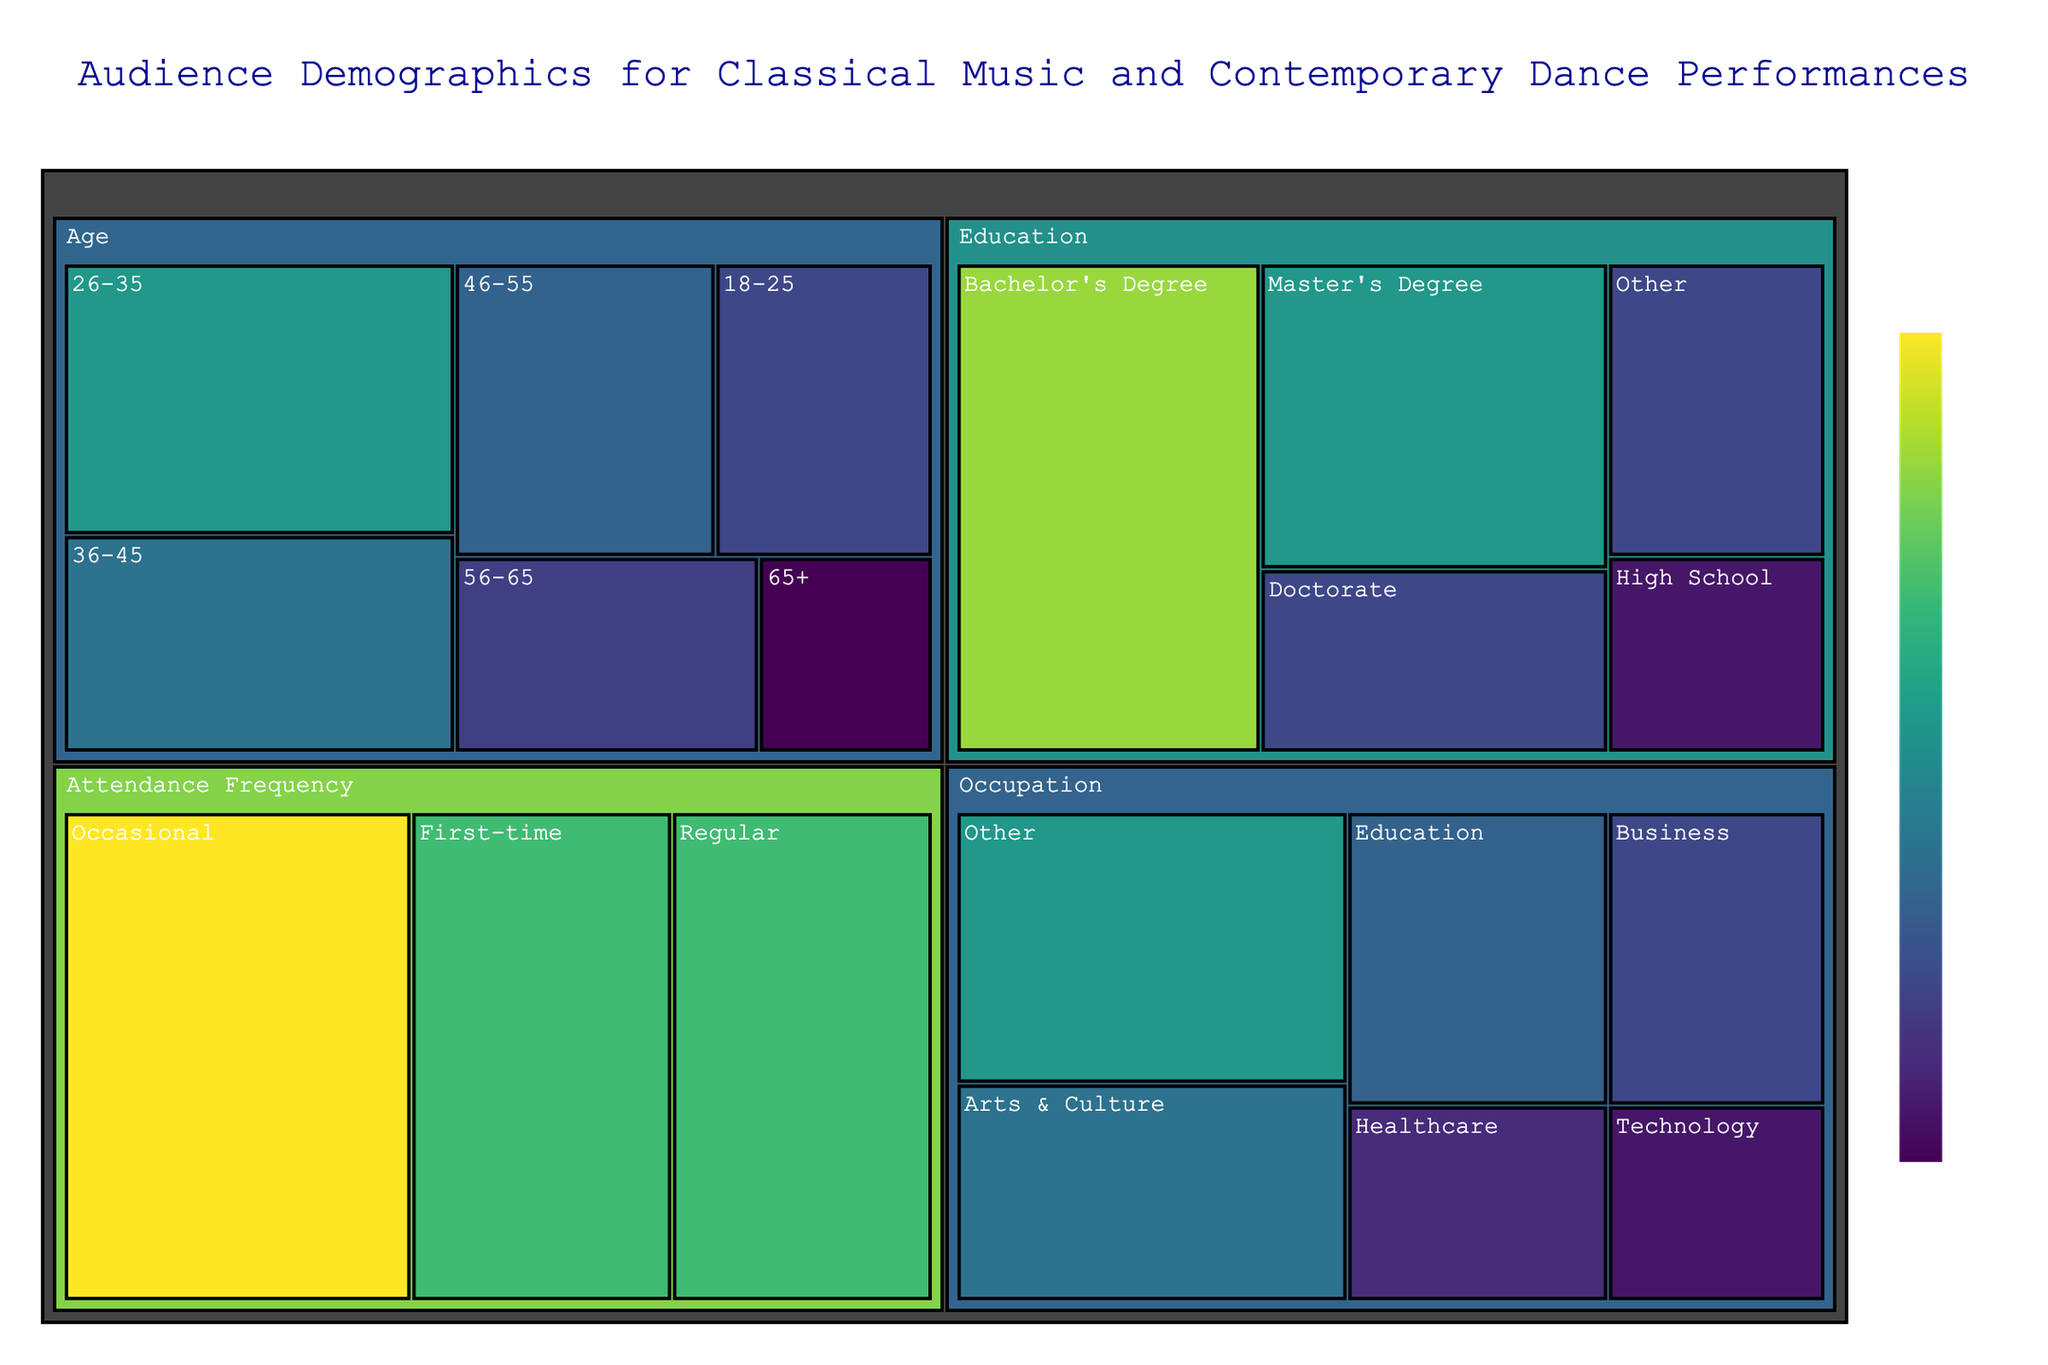What is the total number of audience members in the 18-25 age group? The treemap shows that the value for the 18-25 age group is 15. This information is available directly from the figure.
Answer: 15 What are the categories represented in the treemap? The treemap organizes data into different categories, which are visible as top-level labels. The categories are Age, Education, Occupation, and Attendance Frequency.
Answer: Age, Education, Occupation, Attendance Frequency Which subcategory in the Education category has the highest value? Within the Education category, the treemap shows the subcategories with their values. The Bachelor's Degree subcategory has the highest value at 35.
Answer: Bachelor's Degree What is the combined value of audience members with a Master's Degree and a Doctorate? To find the combined value, add the values of the Master's Degree (25) and Doctorate (15) subcategories. 25 + 15 = 40.
Answer: 40 How does the number of first-time attendees compare to regular attendees? According to the treemap, the value for First-time attendees is 30, while Regular attendees also have a value of 30. Both have the same number.
Answer: Same What percentage of audience members work in Technology? The total number of audience values must be summed first. Then, find the percentage of Technology workers which is 10. Total is 15 + 25 + 20 + 18 + 14 + 8 + 10 + 35 + 25 + 15 + 15 + 20 + 18 + 15 + 12 + 10 + 25 + 30 + 40 + 30 = 350. The percentage is (10/350)*100 ≈ 2.857%.
Answer: 2.857% Which subcategory in the Occupation category has the smallest value? The treemap shows that in the Occupation category, the Technology subcategory has the smallest value at 10.
Answer: Technology What is the sum of the values for the subcategories under Age category? Add the values of the Age subcategories: 15 (18-25) + 25 (26-35) + 20 (36-45) + 18 (46-55) + 14 (56-65) + 8 (65+). 15 + 25 + 20 + 18 + 14 + 8 = 100.
Answer: 100 Which Education subcategory has the same value as the Healthcare subcategory in Occupation? The Healthcare subcategory value is 12, and the comparison with Education subcategories shows that none of them have this exact value.
Answer: None 